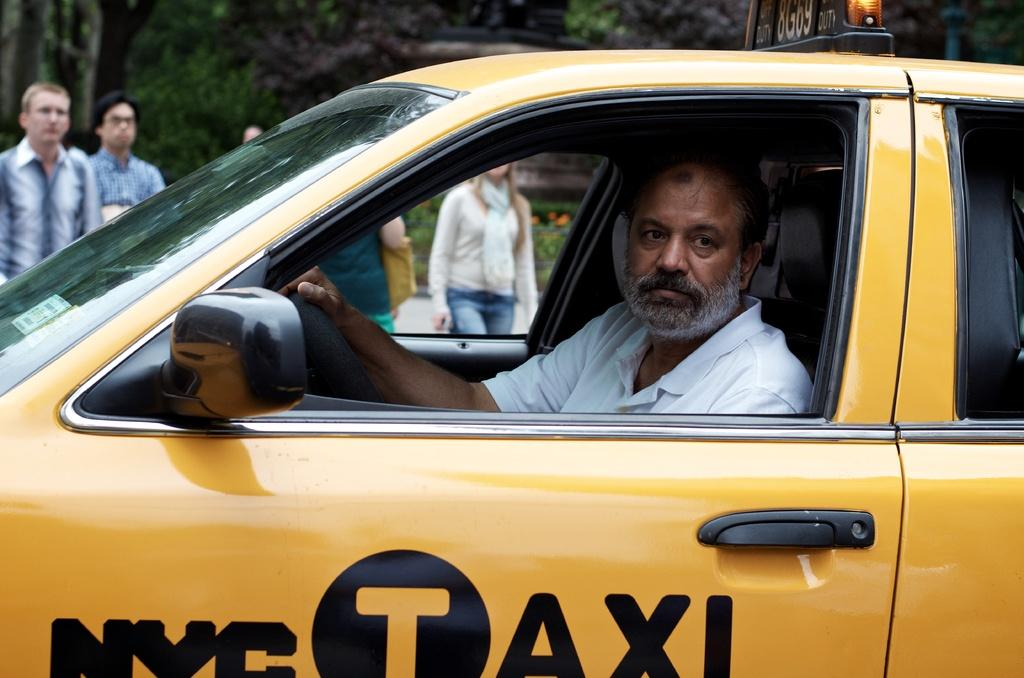<image>
Describe the image concisely. a man wearing a yellow shirt while riding a yellow taxi cab with the nyc logo on the bottom. 